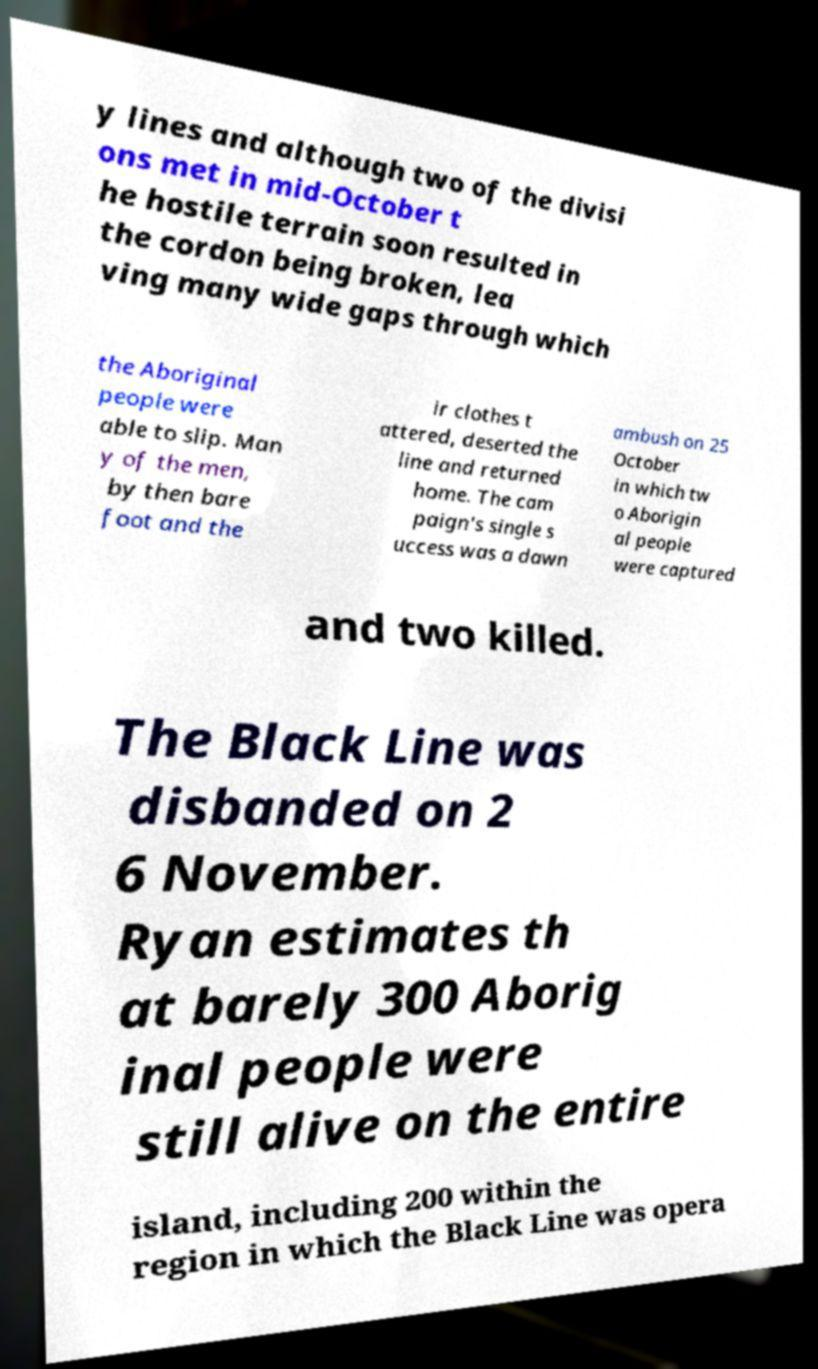There's text embedded in this image that I need extracted. Can you transcribe it verbatim? y lines and although two of the divisi ons met in mid-October t he hostile terrain soon resulted in the cordon being broken, lea ving many wide gaps through which the Aboriginal people were able to slip. Man y of the men, by then bare foot and the ir clothes t attered, deserted the line and returned home. The cam paign's single s uccess was a dawn ambush on 25 October in which tw o Aborigin al people were captured and two killed. The Black Line was disbanded on 2 6 November. Ryan estimates th at barely 300 Aborig inal people were still alive on the entire island, including 200 within the region in which the Black Line was opera 